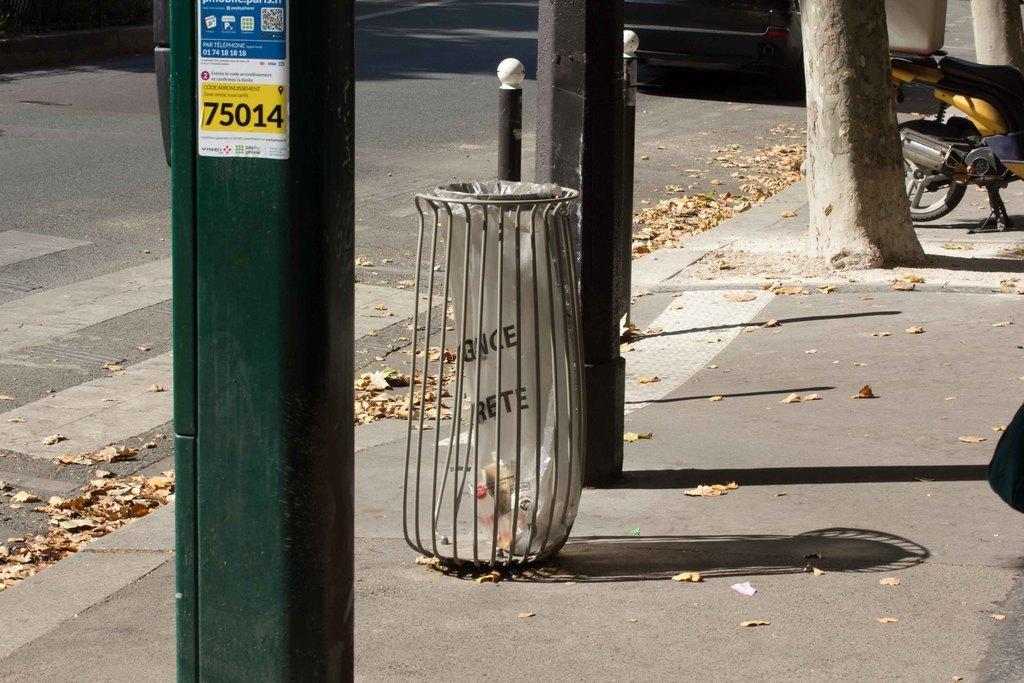Can you describe this image briefly? In this image I can see the road, a sidewalk, few poles on the side walk, a vehicle on the road, a motor bike on the sidewalk, a bin, a tree and few leaves on the ground which are brown in color. 